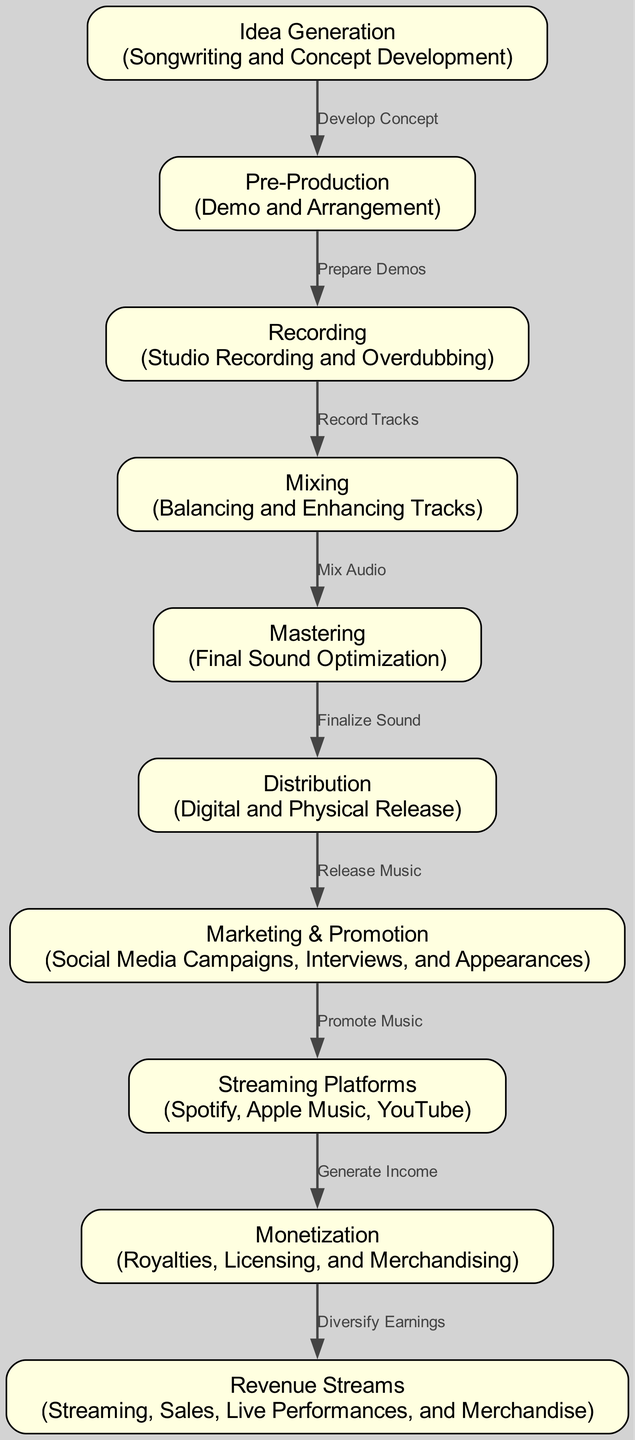What is the first stage in the lifecycle of a hit song? The diagram indicates that the first stage is "Idea Generation." This is evidenced by the starting node in the visualization, which outlines the initial step of songwriting and concept development.
Answer: Idea Generation How many total nodes are present in the diagram? By counting the distinct stages depicted in the diagram, I find there are ten nodes representing different phases in the lifecycle of a hit song.
Answer: 10 What is the final stage before monetization occurs? According to the diagram, the final stage before monetization is "Streaming Platforms." The edge shows a directed flow from the streaming platforms to the monetization process.
Answer: Streaming Platforms Which node is directly connected to the Distribution node? The diagram shows that the "Marketing & Promotion" node is directly connected to the "Distribution" node. The edge label suggests that marketing efforts follow music distribution.
Answer: Marketing & Promotion What is the primary purpose of the "Marketing & Promotion" stage? This stage is about conducting campaigns that promote the music. The node explains that it involves social media campaigns, interviews, and appearances to create buzz.
Answer: Promote Music How do songs generate income according to the diagram? The diagram specifies that songs generate income through the "Streaming Platforms," and this is demonstrated by a direct edge leading from the Streaming Platforms to the Monetization node.
Answer: Generate Income What are the different types of revenue streams mentioned? The "Revenue Streams" node lists multiple forms of income including streaming, sales, live performances, and merchandise, combining several avenues through which artists can earn.
Answer: Streaming, Sales, Live Performances, Merchandise What action follows the "Mastering" phase in the song creation process? Following the "Mastering" phase, the next action is "Distribution," which refers to the finalization of the sound leading to the release of music to the public.
Answer: Distribution Which stage involves developing a concept for the song? The stage where the concept for the song is developed is the "Idea Generation" stage, as indicated by the label and description associated with that node.
Answer: Idea Generation 